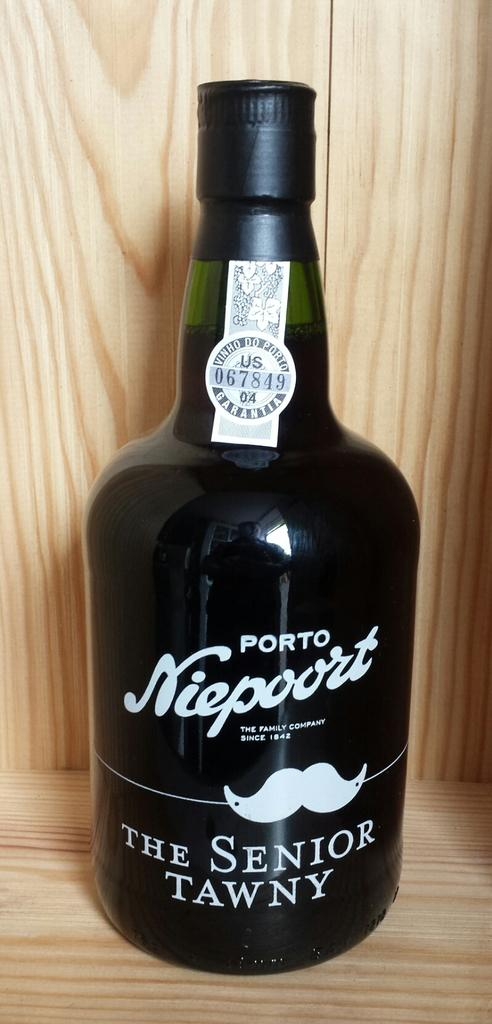<image>
Share a concise interpretation of the image provided. A black bottle with white text says The Senior Tawny. 